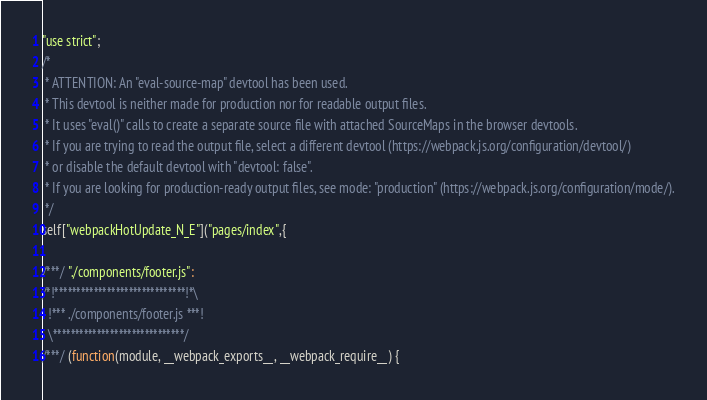Convert code to text. <code><loc_0><loc_0><loc_500><loc_500><_JavaScript_>"use strict";
/*
 * ATTENTION: An "eval-source-map" devtool has been used.
 * This devtool is neither made for production nor for readable output files.
 * It uses "eval()" calls to create a separate source file with attached SourceMaps in the browser devtools.
 * If you are trying to read the output file, select a different devtool (https://webpack.js.org/configuration/devtool/)
 * or disable the default devtool with "devtool: false".
 * If you are looking for production-ready output files, see mode: "production" (https://webpack.js.org/configuration/mode/).
 */
self["webpackHotUpdate_N_E"]("pages/index",{

/***/ "./components/footer.js":
/*!******************************!*\
  !*** ./components/footer.js ***!
  \******************************/
/***/ (function(module, __webpack_exports__, __webpack_require__) {
</code> 